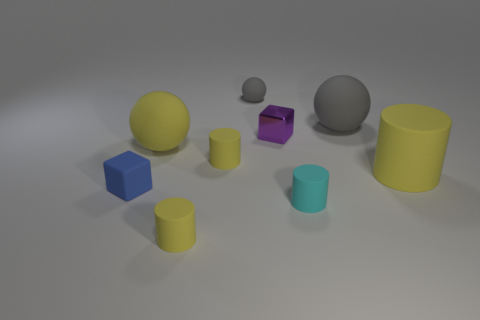How many tiny yellow cylinders are the same material as the large yellow cylinder?
Ensure brevity in your answer.  2. Are there the same number of small shiny things that are on the right side of the big gray object and large cyan metal cylinders?
Provide a short and direct response. Yes. What is the material of the big thing that is the same color as the tiny ball?
Your answer should be very brief. Rubber. There is a cyan thing; is its size the same as the gray ball on the right side of the tiny cyan matte cylinder?
Offer a very short reply. No. What number of other things are the same size as the purple thing?
Provide a succinct answer. 5. How many other things are the same color as the metallic block?
Offer a terse response. 0. How many other things are the same shape as the purple shiny object?
Your answer should be very brief. 1. Is the size of the blue rubber object the same as the shiny thing?
Keep it short and to the point. Yes. Is there a small rubber sphere?
Your answer should be very brief. Yes. Is there anything else that is the same material as the purple object?
Make the answer very short. No. 